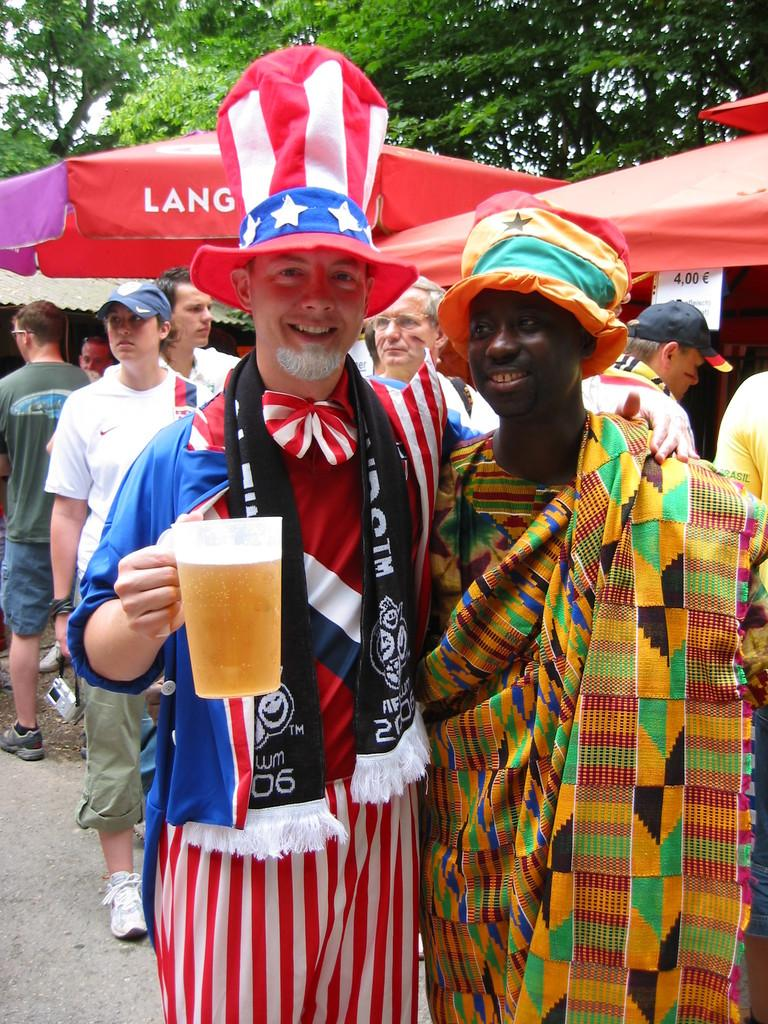<image>
Give a short and clear explanation of the subsequent image. A person in an Uncle Sam costume is wearing a scarf with the year 2006 on it. 